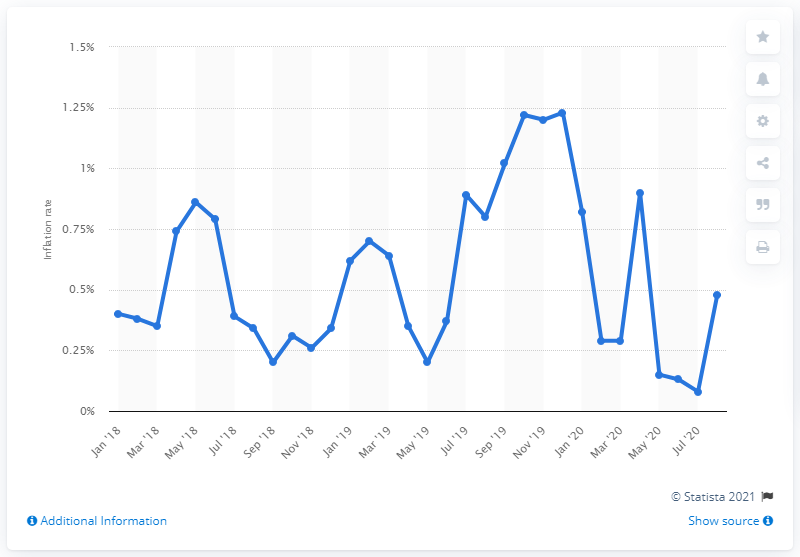Outline some significant characteristics in this image. The inflation rate for clothing and footwear products in Belgium in August 2020 was 0.48%. In August 2020, the consumer price index was 0.4. 